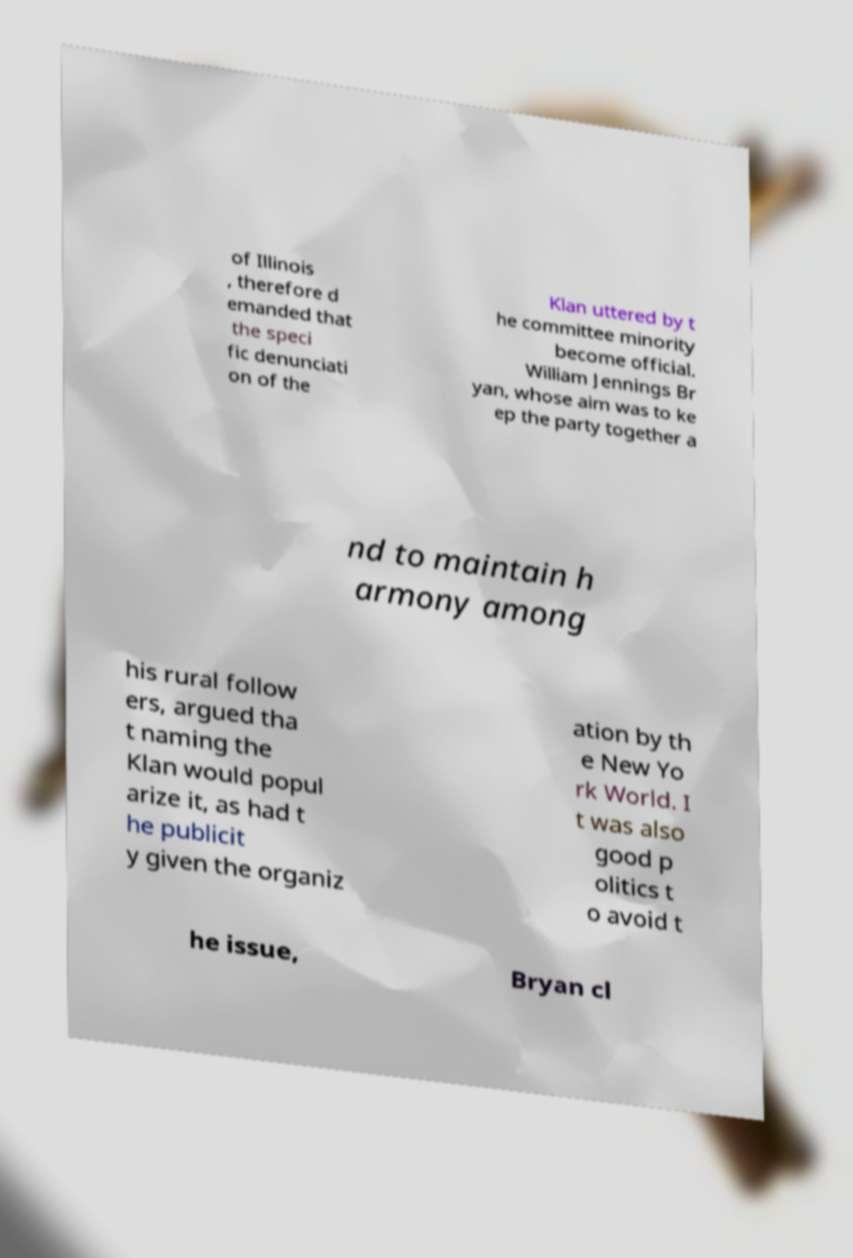What messages or text are displayed in this image? I need them in a readable, typed format. of Illinois , therefore d emanded that the speci fic denunciati on of the Klan uttered by t he committee minority become official. William Jennings Br yan, whose aim was to ke ep the party together a nd to maintain h armony among his rural follow ers, argued tha t naming the Klan would popul arize it, as had t he publicit y given the organiz ation by th e New Yo rk World. I t was also good p olitics t o avoid t he issue, Bryan cl 